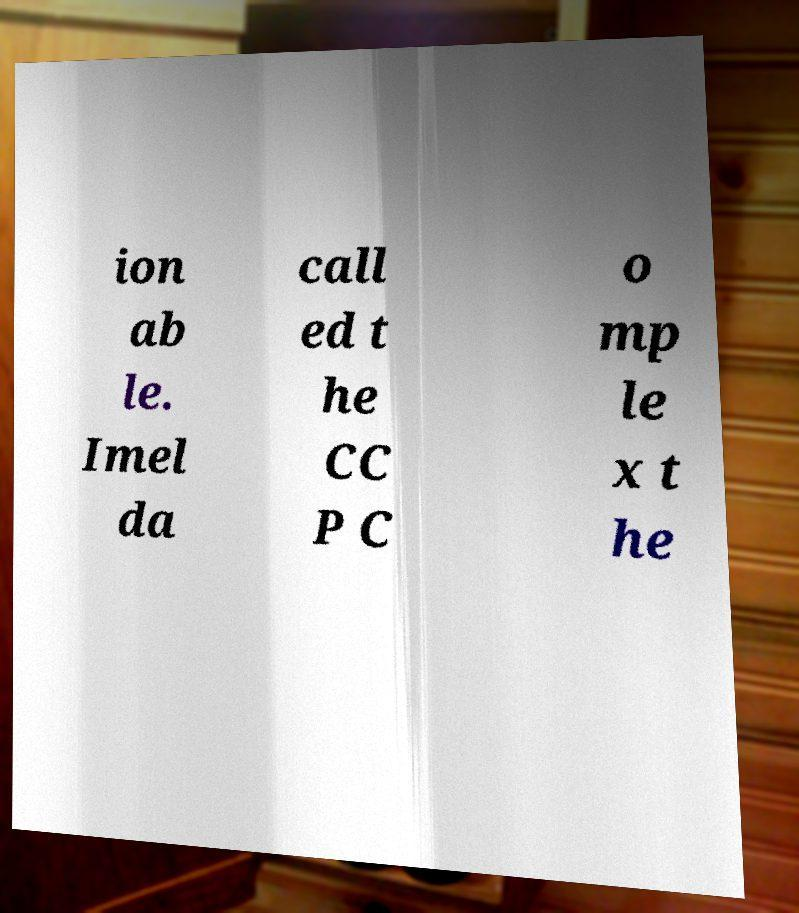There's text embedded in this image that I need extracted. Can you transcribe it verbatim? ion ab le. Imel da call ed t he CC P C o mp le x t he 